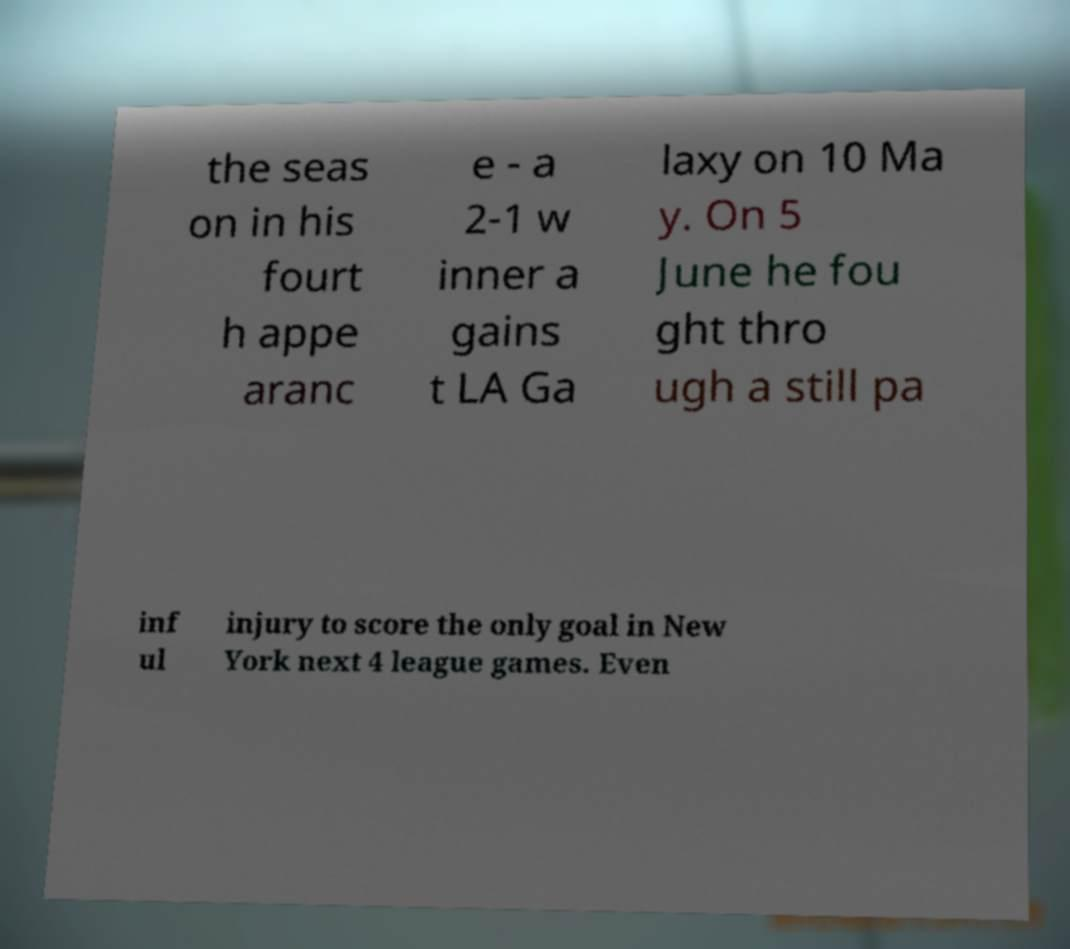Can you read and provide the text displayed in the image?This photo seems to have some interesting text. Can you extract and type it out for me? the seas on in his fourt h appe aranc e - a 2-1 w inner a gains t LA Ga laxy on 10 Ma y. On 5 June he fou ght thro ugh a still pa inf ul injury to score the only goal in New York next 4 league games. Even 